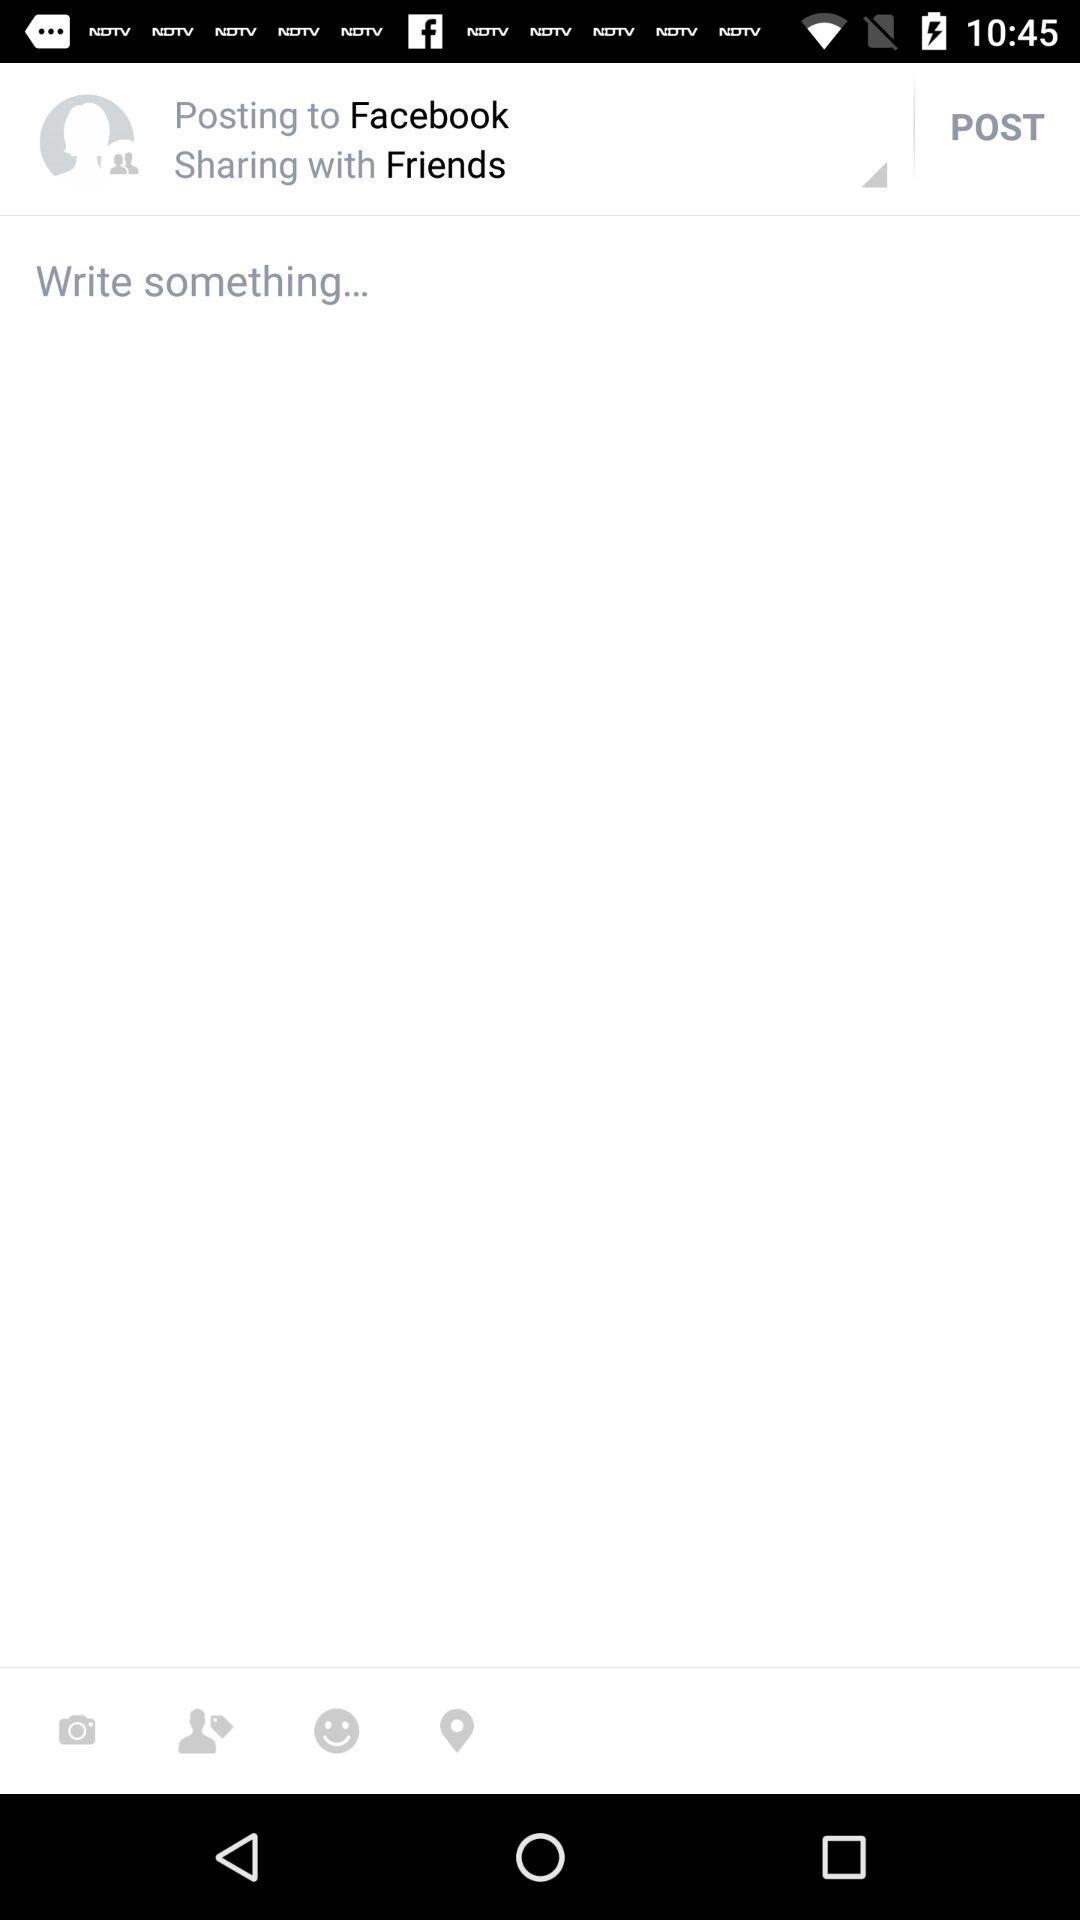What is the selected privacy for sharing? The selected privacy for sharing is with friends. 